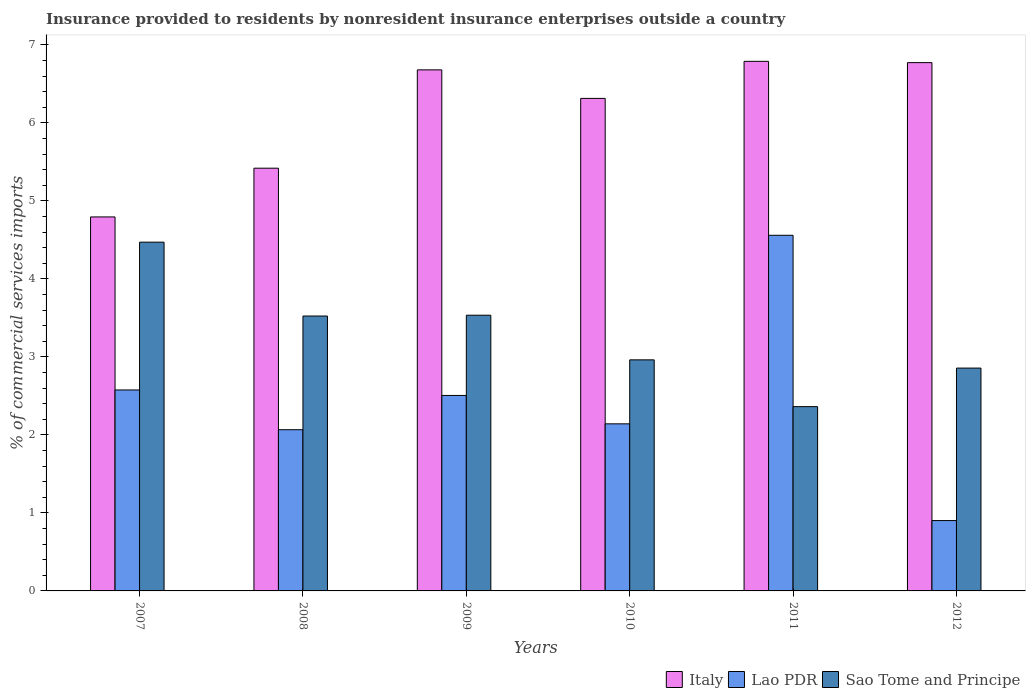Are the number of bars on each tick of the X-axis equal?
Your answer should be compact. Yes. How many bars are there on the 3rd tick from the left?
Give a very brief answer. 3. In how many cases, is the number of bars for a given year not equal to the number of legend labels?
Keep it short and to the point. 0. What is the Insurance provided to residents in Lao PDR in 2009?
Give a very brief answer. 2.51. Across all years, what is the maximum Insurance provided to residents in Lao PDR?
Offer a terse response. 4.56. Across all years, what is the minimum Insurance provided to residents in Italy?
Provide a succinct answer. 4.79. In which year was the Insurance provided to residents in Sao Tome and Principe maximum?
Give a very brief answer. 2007. In which year was the Insurance provided to residents in Sao Tome and Principe minimum?
Provide a short and direct response. 2011. What is the total Insurance provided to residents in Italy in the graph?
Offer a terse response. 36.77. What is the difference between the Insurance provided to residents in Italy in 2007 and that in 2012?
Keep it short and to the point. -1.98. What is the difference between the Insurance provided to residents in Lao PDR in 2008 and the Insurance provided to residents in Italy in 2009?
Your response must be concise. -4.61. What is the average Insurance provided to residents in Sao Tome and Principe per year?
Your answer should be very brief. 3.28. In the year 2012, what is the difference between the Insurance provided to residents in Sao Tome and Principe and Insurance provided to residents in Italy?
Give a very brief answer. -3.92. What is the ratio of the Insurance provided to residents in Italy in 2008 to that in 2010?
Your answer should be very brief. 0.86. What is the difference between the highest and the second highest Insurance provided to residents in Sao Tome and Principe?
Offer a very short reply. 0.94. What is the difference between the highest and the lowest Insurance provided to residents in Sao Tome and Principe?
Your answer should be compact. 2.11. In how many years, is the Insurance provided to residents in Sao Tome and Principe greater than the average Insurance provided to residents in Sao Tome and Principe taken over all years?
Your answer should be very brief. 3. What does the 3rd bar from the left in 2012 represents?
Provide a succinct answer. Sao Tome and Principe. What does the 1st bar from the right in 2012 represents?
Ensure brevity in your answer.  Sao Tome and Principe. Is it the case that in every year, the sum of the Insurance provided to residents in Italy and Insurance provided to residents in Sao Tome and Principe is greater than the Insurance provided to residents in Lao PDR?
Your answer should be compact. Yes. What is the difference between two consecutive major ticks on the Y-axis?
Your answer should be compact. 1. Are the values on the major ticks of Y-axis written in scientific E-notation?
Make the answer very short. No. Does the graph contain grids?
Offer a very short reply. No. Where does the legend appear in the graph?
Offer a very short reply. Bottom right. How many legend labels are there?
Make the answer very short. 3. How are the legend labels stacked?
Provide a succinct answer. Horizontal. What is the title of the graph?
Provide a succinct answer. Insurance provided to residents by nonresident insurance enterprises outside a country. What is the label or title of the Y-axis?
Ensure brevity in your answer.  % of commercial services imports. What is the % of commercial services imports of Italy in 2007?
Keep it short and to the point. 4.79. What is the % of commercial services imports of Lao PDR in 2007?
Provide a succinct answer. 2.58. What is the % of commercial services imports of Sao Tome and Principe in 2007?
Offer a very short reply. 4.47. What is the % of commercial services imports in Italy in 2008?
Provide a short and direct response. 5.42. What is the % of commercial services imports in Lao PDR in 2008?
Provide a short and direct response. 2.07. What is the % of commercial services imports in Sao Tome and Principe in 2008?
Provide a short and direct response. 3.52. What is the % of commercial services imports of Italy in 2009?
Offer a very short reply. 6.68. What is the % of commercial services imports in Lao PDR in 2009?
Offer a very short reply. 2.51. What is the % of commercial services imports of Sao Tome and Principe in 2009?
Your response must be concise. 3.53. What is the % of commercial services imports in Italy in 2010?
Your answer should be compact. 6.31. What is the % of commercial services imports of Lao PDR in 2010?
Your answer should be very brief. 2.14. What is the % of commercial services imports in Sao Tome and Principe in 2010?
Your answer should be compact. 2.96. What is the % of commercial services imports of Italy in 2011?
Offer a very short reply. 6.79. What is the % of commercial services imports of Lao PDR in 2011?
Provide a short and direct response. 4.56. What is the % of commercial services imports in Sao Tome and Principe in 2011?
Your answer should be very brief. 2.36. What is the % of commercial services imports of Italy in 2012?
Your response must be concise. 6.77. What is the % of commercial services imports of Lao PDR in 2012?
Make the answer very short. 0.9. What is the % of commercial services imports in Sao Tome and Principe in 2012?
Offer a terse response. 2.86. Across all years, what is the maximum % of commercial services imports of Italy?
Offer a very short reply. 6.79. Across all years, what is the maximum % of commercial services imports in Lao PDR?
Offer a terse response. 4.56. Across all years, what is the maximum % of commercial services imports in Sao Tome and Principe?
Provide a succinct answer. 4.47. Across all years, what is the minimum % of commercial services imports in Italy?
Your answer should be compact. 4.79. Across all years, what is the minimum % of commercial services imports in Lao PDR?
Provide a short and direct response. 0.9. Across all years, what is the minimum % of commercial services imports in Sao Tome and Principe?
Offer a terse response. 2.36. What is the total % of commercial services imports in Italy in the graph?
Provide a short and direct response. 36.77. What is the total % of commercial services imports in Lao PDR in the graph?
Offer a very short reply. 14.75. What is the total % of commercial services imports in Sao Tome and Principe in the graph?
Provide a succinct answer. 19.71. What is the difference between the % of commercial services imports of Italy in 2007 and that in 2008?
Offer a very short reply. -0.62. What is the difference between the % of commercial services imports of Lao PDR in 2007 and that in 2008?
Keep it short and to the point. 0.51. What is the difference between the % of commercial services imports in Sao Tome and Principe in 2007 and that in 2008?
Give a very brief answer. 0.95. What is the difference between the % of commercial services imports of Italy in 2007 and that in 2009?
Your answer should be compact. -1.89. What is the difference between the % of commercial services imports of Lao PDR in 2007 and that in 2009?
Ensure brevity in your answer.  0.07. What is the difference between the % of commercial services imports in Sao Tome and Principe in 2007 and that in 2009?
Give a very brief answer. 0.94. What is the difference between the % of commercial services imports of Italy in 2007 and that in 2010?
Give a very brief answer. -1.52. What is the difference between the % of commercial services imports of Lao PDR in 2007 and that in 2010?
Your response must be concise. 0.43. What is the difference between the % of commercial services imports of Sao Tome and Principe in 2007 and that in 2010?
Ensure brevity in your answer.  1.51. What is the difference between the % of commercial services imports in Italy in 2007 and that in 2011?
Provide a short and direct response. -1.99. What is the difference between the % of commercial services imports of Lao PDR in 2007 and that in 2011?
Ensure brevity in your answer.  -1.98. What is the difference between the % of commercial services imports of Sao Tome and Principe in 2007 and that in 2011?
Keep it short and to the point. 2.11. What is the difference between the % of commercial services imports of Italy in 2007 and that in 2012?
Ensure brevity in your answer.  -1.98. What is the difference between the % of commercial services imports of Lao PDR in 2007 and that in 2012?
Make the answer very short. 1.67. What is the difference between the % of commercial services imports of Sao Tome and Principe in 2007 and that in 2012?
Your response must be concise. 1.61. What is the difference between the % of commercial services imports of Italy in 2008 and that in 2009?
Your response must be concise. -1.26. What is the difference between the % of commercial services imports of Lao PDR in 2008 and that in 2009?
Ensure brevity in your answer.  -0.44. What is the difference between the % of commercial services imports in Sao Tome and Principe in 2008 and that in 2009?
Your response must be concise. -0.01. What is the difference between the % of commercial services imports in Italy in 2008 and that in 2010?
Your answer should be very brief. -0.89. What is the difference between the % of commercial services imports in Lao PDR in 2008 and that in 2010?
Your answer should be compact. -0.08. What is the difference between the % of commercial services imports of Sao Tome and Principe in 2008 and that in 2010?
Keep it short and to the point. 0.56. What is the difference between the % of commercial services imports of Italy in 2008 and that in 2011?
Provide a succinct answer. -1.37. What is the difference between the % of commercial services imports of Lao PDR in 2008 and that in 2011?
Your answer should be compact. -2.49. What is the difference between the % of commercial services imports in Sao Tome and Principe in 2008 and that in 2011?
Offer a terse response. 1.16. What is the difference between the % of commercial services imports in Italy in 2008 and that in 2012?
Make the answer very short. -1.35. What is the difference between the % of commercial services imports in Lao PDR in 2008 and that in 2012?
Keep it short and to the point. 1.16. What is the difference between the % of commercial services imports of Sao Tome and Principe in 2008 and that in 2012?
Keep it short and to the point. 0.67. What is the difference between the % of commercial services imports in Italy in 2009 and that in 2010?
Your answer should be very brief. 0.37. What is the difference between the % of commercial services imports in Lao PDR in 2009 and that in 2010?
Make the answer very short. 0.36. What is the difference between the % of commercial services imports of Sao Tome and Principe in 2009 and that in 2010?
Offer a terse response. 0.57. What is the difference between the % of commercial services imports of Italy in 2009 and that in 2011?
Provide a succinct answer. -0.11. What is the difference between the % of commercial services imports in Lao PDR in 2009 and that in 2011?
Your answer should be compact. -2.05. What is the difference between the % of commercial services imports of Sao Tome and Principe in 2009 and that in 2011?
Keep it short and to the point. 1.17. What is the difference between the % of commercial services imports of Italy in 2009 and that in 2012?
Offer a very short reply. -0.09. What is the difference between the % of commercial services imports of Lao PDR in 2009 and that in 2012?
Make the answer very short. 1.6. What is the difference between the % of commercial services imports of Sao Tome and Principe in 2009 and that in 2012?
Make the answer very short. 0.68. What is the difference between the % of commercial services imports in Italy in 2010 and that in 2011?
Give a very brief answer. -0.47. What is the difference between the % of commercial services imports of Lao PDR in 2010 and that in 2011?
Offer a terse response. -2.42. What is the difference between the % of commercial services imports in Sao Tome and Principe in 2010 and that in 2011?
Provide a succinct answer. 0.6. What is the difference between the % of commercial services imports of Italy in 2010 and that in 2012?
Give a very brief answer. -0.46. What is the difference between the % of commercial services imports in Lao PDR in 2010 and that in 2012?
Offer a very short reply. 1.24. What is the difference between the % of commercial services imports in Sao Tome and Principe in 2010 and that in 2012?
Provide a succinct answer. 0.11. What is the difference between the % of commercial services imports of Italy in 2011 and that in 2012?
Your answer should be very brief. 0.02. What is the difference between the % of commercial services imports in Lao PDR in 2011 and that in 2012?
Provide a short and direct response. 3.66. What is the difference between the % of commercial services imports of Sao Tome and Principe in 2011 and that in 2012?
Keep it short and to the point. -0.49. What is the difference between the % of commercial services imports in Italy in 2007 and the % of commercial services imports in Lao PDR in 2008?
Offer a very short reply. 2.73. What is the difference between the % of commercial services imports of Italy in 2007 and the % of commercial services imports of Sao Tome and Principe in 2008?
Your response must be concise. 1.27. What is the difference between the % of commercial services imports in Lao PDR in 2007 and the % of commercial services imports in Sao Tome and Principe in 2008?
Offer a terse response. -0.95. What is the difference between the % of commercial services imports in Italy in 2007 and the % of commercial services imports in Lao PDR in 2009?
Ensure brevity in your answer.  2.29. What is the difference between the % of commercial services imports in Italy in 2007 and the % of commercial services imports in Sao Tome and Principe in 2009?
Provide a succinct answer. 1.26. What is the difference between the % of commercial services imports in Lao PDR in 2007 and the % of commercial services imports in Sao Tome and Principe in 2009?
Your response must be concise. -0.96. What is the difference between the % of commercial services imports of Italy in 2007 and the % of commercial services imports of Lao PDR in 2010?
Make the answer very short. 2.65. What is the difference between the % of commercial services imports in Italy in 2007 and the % of commercial services imports in Sao Tome and Principe in 2010?
Offer a very short reply. 1.83. What is the difference between the % of commercial services imports of Lao PDR in 2007 and the % of commercial services imports of Sao Tome and Principe in 2010?
Provide a short and direct response. -0.39. What is the difference between the % of commercial services imports of Italy in 2007 and the % of commercial services imports of Lao PDR in 2011?
Your answer should be very brief. 0.24. What is the difference between the % of commercial services imports in Italy in 2007 and the % of commercial services imports in Sao Tome and Principe in 2011?
Keep it short and to the point. 2.43. What is the difference between the % of commercial services imports in Lao PDR in 2007 and the % of commercial services imports in Sao Tome and Principe in 2011?
Give a very brief answer. 0.21. What is the difference between the % of commercial services imports in Italy in 2007 and the % of commercial services imports in Lao PDR in 2012?
Your response must be concise. 3.89. What is the difference between the % of commercial services imports in Italy in 2007 and the % of commercial services imports in Sao Tome and Principe in 2012?
Keep it short and to the point. 1.94. What is the difference between the % of commercial services imports in Lao PDR in 2007 and the % of commercial services imports in Sao Tome and Principe in 2012?
Provide a short and direct response. -0.28. What is the difference between the % of commercial services imports of Italy in 2008 and the % of commercial services imports of Lao PDR in 2009?
Your answer should be compact. 2.91. What is the difference between the % of commercial services imports of Italy in 2008 and the % of commercial services imports of Sao Tome and Principe in 2009?
Your answer should be compact. 1.88. What is the difference between the % of commercial services imports of Lao PDR in 2008 and the % of commercial services imports of Sao Tome and Principe in 2009?
Provide a succinct answer. -1.47. What is the difference between the % of commercial services imports of Italy in 2008 and the % of commercial services imports of Lao PDR in 2010?
Give a very brief answer. 3.28. What is the difference between the % of commercial services imports in Italy in 2008 and the % of commercial services imports in Sao Tome and Principe in 2010?
Give a very brief answer. 2.46. What is the difference between the % of commercial services imports of Lao PDR in 2008 and the % of commercial services imports of Sao Tome and Principe in 2010?
Provide a succinct answer. -0.9. What is the difference between the % of commercial services imports in Italy in 2008 and the % of commercial services imports in Lao PDR in 2011?
Your response must be concise. 0.86. What is the difference between the % of commercial services imports of Italy in 2008 and the % of commercial services imports of Sao Tome and Principe in 2011?
Keep it short and to the point. 3.06. What is the difference between the % of commercial services imports of Lao PDR in 2008 and the % of commercial services imports of Sao Tome and Principe in 2011?
Ensure brevity in your answer.  -0.3. What is the difference between the % of commercial services imports of Italy in 2008 and the % of commercial services imports of Lao PDR in 2012?
Your answer should be very brief. 4.52. What is the difference between the % of commercial services imports in Italy in 2008 and the % of commercial services imports in Sao Tome and Principe in 2012?
Provide a succinct answer. 2.56. What is the difference between the % of commercial services imports in Lao PDR in 2008 and the % of commercial services imports in Sao Tome and Principe in 2012?
Keep it short and to the point. -0.79. What is the difference between the % of commercial services imports of Italy in 2009 and the % of commercial services imports of Lao PDR in 2010?
Make the answer very short. 4.54. What is the difference between the % of commercial services imports in Italy in 2009 and the % of commercial services imports in Sao Tome and Principe in 2010?
Offer a very short reply. 3.72. What is the difference between the % of commercial services imports of Lao PDR in 2009 and the % of commercial services imports of Sao Tome and Principe in 2010?
Ensure brevity in your answer.  -0.46. What is the difference between the % of commercial services imports of Italy in 2009 and the % of commercial services imports of Lao PDR in 2011?
Ensure brevity in your answer.  2.12. What is the difference between the % of commercial services imports in Italy in 2009 and the % of commercial services imports in Sao Tome and Principe in 2011?
Your answer should be compact. 4.32. What is the difference between the % of commercial services imports of Lao PDR in 2009 and the % of commercial services imports of Sao Tome and Principe in 2011?
Keep it short and to the point. 0.14. What is the difference between the % of commercial services imports in Italy in 2009 and the % of commercial services imports in Lao PDR in 2012?
Provide a short and direct response. 5.78. What is the difference between the % of commercial services imports of Italy in 2009 and the % of commercial services imports of Sao Tome and Principe in 2012?
Provide a succinct answer. 3.82. What is the difference between the % of commercial services imports in Lao PDR in 2009 and the % of commercial services imports in Sao Tome and Principe in 2012?
Provide a succinct answer. -0.35. What is the difference between the % of commercial services imports of Italy in 2010 and the % of commercial services imports of Lao PDR in 2011?
Offer a terse response. 1.75. What is the difference between the % of commercial services imports in Italy in 2010 and the % of commercial services imports in Sao Tome and Principe in 2011?
Keep it short and to the point. 3.95. What is the difference between the % of commercial services imports of Lao PDR in 2010 and the % of commercial services imports of Sao Tome and Principe in 2011?
Your response must be concise. -0.22. What is the difference between the % of commercial services imports in Italy in 2010 and the % of commercial services imports in Lao PDR in 2012?
Offer a terse response. 5.41. What is the difference between the % of commercial services imports of Italy in 2010 and the % of commercial services imports of Sao Tome and Principe in 2012?
Provide a short and direct response. 3.46. What is the difference between the % of commercial services imports of Lao PDR in 2010 and the % of commercial services imports of Sao Tome and Principe in 2012?
Give a very brief answer. -0.71. What is the difference between the % of commercial services imports of Italy in 2011 and the % of commercial services imports of Lao PDR in 2012?
Ensure brevity in your answer.  5.89. What is the difference between the % of commercial services imports of Italy in 2011 and the % of commercial services imports of Sao Tome and Principe in 2012?
Offer a very short reply. 3.93. What is the difference between the % of commercial services imports in Lao PDR in 2011 and the % of commercial services imports in Sao Tome and Principe in 2012?
Ensure brevity in your answer.  1.7. What is the average % of commercial services imports in Italy per year?
Your response must be concise. 6.13. What is the average % of commercial services imports in Lao PDR per year?
Your answer should be compact. 2.46. What is the average % of commercial services imports in Sao Tome and Principe per year?
Your answer should be very brief. 3.29. In the year 2007, what is the difference between the % of commercial services imports of Italy and % of commercial services imports of Lao PDR?
Keep it short and to the point. 2.22. In the year 2007, what is the difference between the % of commercial services imports in Italy and % of commercial services imports in Sao Tome and Principe?
Offer a terse response. 0.32. In the year 2007, what is the difference between the % of commercial services imports in Lao PDR and % of commercial services imports in Sao Tome and Principe?
Provide a succinct answer. -1.89. In the year 2008, what is the difference between the % of commercial services imports in Italy and % of commercial services imports in Lao PDR?
Your response must be concise. 3.35. In the year 2008, what is the difference between the % of commercial services imports in Italy and % of commercial services imports in Sao Tome and Principe?
Provide a short and direct response. 1.9. In the year 2008, what is the difference between the % of commercial services imports of Lao PDR and % of commercial services imports of Sao Tome and Principe?
Ensure brevity in your answer.  -1.46. In the year 2009, what is the difference between the % of commercial services imports in Italy and % of commercial services imports in Lao PDR?
Your response must be concise. 4.17. In the year 2009, what is the difference between the % of commercial services imports of Italy and % of commercial services imports of Sao Tome and Principe?
Provide a short and direct response. 3.15. In the year 2009, what is the difference between the % of commercial services imports in Lao PDR and % of commercial services imports in Sao Tome and Principe?
Offer a terse response. -1.03. In the year 2010, what is the difference between the % of commercial services imports in Italy and % of commercial services imports in Lao PDR?
Provide a succinct answer. 4.17. In the year 2010, what is the difference between the % of commercial services imports of Italy and % of commercial services imports of Sao Tome and Principe?
Give a very brief answer. 3.35. In the year 2010, what is the difference between the % of commercial services imports of Lao PDR and % of commercial services imports of Sao Tome and Principe?
Offer a very short reply. -0.82. In the year 2011, what is the difference between the % of commercial services imports of Italy and % of commercial services imports of Lao PDR?
Give a very brief answer. 2.23. In the year 2011, what is the difference between the % of commercial services imports in Italy and % of commercial services imports in Sao Tome and Principe?
Provide a short and direct response. 4.43. In the year 2011, what is the difference between the % of commercial services imports in Lao PDR and % of commercial services imports in Sao Tome and Principe?
Your response must be concise. 2.2. In the year 2012, what is the difference between the % of commercial services imports in Italy and % of commercial services imports in Lao PDR?
Your response must be concise. 5.87. In the year 2012, what is the difference between the % of commercial services imports of Italy and % of commercial services imports of Sao Tome and Principe?
Give a very brief answer. 3.92. In the year 2012, what is the difference between the % of commercial services imports of Lao PDR and % of commercial services imports of Sao Tome and Principe?
Your answer should be compact. -1.95. What is the ratio of the % of commercial services imports of Italy in 2007 to that in 2008?
Provide a succinct answer. 0.88. What is the ratio of the % of commercial services imports of Lao PDR in 2007 to that in 2008?
Provide a short and direct response. 1.25. What is the ratio of the % of commercial services imports in Sao Tome and Principe in 2007 to that in 2008?
Make the answer very short. 1.27. What is the ratio of the % of commercial services imports in Italy in 2007 to that in 2009?
Provide a succinct answer. 0.72. What is the ratio of the % of commercial services imports of Lao PDR in 2007 to that in 2009?
Give a very brief answer. 1.03. What is the ratio of the % of commercial services imports in Sao Tome and Principe in 2007 to that in 2009?
Offer a very short reply. 1.26. What is the ratio of the % of commercial services imports in Italy in 2007 to that in 2010?
Provide a short and direct response. 0.76. What is the ratio of the % of commercial services imports of Lao PDR in 2007 to that in 2010?
Give a very brief answer. 1.2. What is the ratio of the % of commercial services imports of Sao Tome and Principe in 2007 to that in 2010?
Offer a terse response. 1.51. What is the ratio of the % of commercial services imports in Italy in 2007 to that in 2011?
Your answer should be compact. 0.71. What is the ratio of the % of commercial services imports in Lao PDR in 2007 to that in 2011?
Your answer should be compact. 0.57. What is the ratio of the % of commercial services imports of Sao Tome and Principe in 2007 to that in 2011?
Keep it short and to the point. 1.89. What is the ratio of the % of commercial services imports in Italy in 2007 to that in 2012?
Keep it short and to the point. 0.71. What is the ratio of the % of commercial services imports in Lao PDR in 2007 to that in 2012?
Your answer should be compact. 2.86. What is the ratio of the % of commercial services imports of Sao Tome and Principe in 2007 to that in 2012?
Keep it short and to the point. 1.56. What is the ratio of the % of commercial services imports in Italy in 2008 to that in 2009?
Provide a short and direct response. 0.81. What is the ratio of the % of commercial services imports in Lao PDR in 2008 to that in 2009?
Your answer should be compact. 0.82. What is the ratio of the % of commercial services imports in Italy in 2008 to that in 2010?
Offer a terse response. 0.86. What is the ratio of the % of commercial services imports in Lao PDR in 2008 to that in 2010?
Your response must be concise. 0.96. What is the ratio of the % of commercial services imports in Sao Tome and Principe in 2008 to that in 2010?
Give a very brief answer. 1.19. What is the ratio of the % of commercial services imports in Italy in 2008 to that in 2011?
Keep it short and to the point. 0.8. What is the ratio of the % of commercial services imports of Lao PDR in 2008 to that in 2011?
Your answer should be very brief. 0.45. What is the ratio of the % of commercial services imports of Sao Tome and Principe in 2008 to that in 2011?
Make the answer very short. 1.49. What is the ratio of the % of commercial services imports in Italy in 2008 to that in 2012?
Provide a short and direct response. 0.8. What is the ratio of the % of commercial services imports of Lao PDR in 2008 to that in 2012?
Your answer should be compact. 2.29. What is the ratio of the % of commercial services imports of Sao Tome and Principe in 2008 to that in 2012?
Make the answer very short. 1.23. What is the ratio of the % of commercial services imports of Italy in 2009 to that in 2010?
Give a very brief answer. 1.06. What is the ratio of the % of commercial services imports in Lao PDR in 2009 to that in 2010?
Give a very brief answer. 1.17. What is the ratio of the % of commercial services imports of Sao Tome and Principe in 2009 to that in 2010?
Provide a short and direct response. 1.19. What is the ratio of the % of commercial services imports in Italy in 2009 to that in 2011?
Make the answer very short. 0.98. What is the ratio of the % of commercial services imports in Lao PDR in 2009 to that in 2011?
Your answer should be very brief. 0.55. What is the ratio of the % of commercial services imports in Sao Tome and Principe in 2009 to that in 2011?
Ensure brevity in your answer.  1.5. What is the ratio of the % of commercial services imports in Italy in 2009 to that in 2012?
Provide a short and direct response. 0.99. What is the ratio of the % of commercial services imports of Lao PDR in 2009 to that in 2012?
Offer a terse response. 2.78. What is the ratio of the % of commercial services imports in Sao Tome and Principe in 2009 to that in 2012?
Offer a terse response. 1.24. What is the ratio of the % of commercial services imports in Italy in 2010 to that in 2011?
Offer a terse response. 0.93. What is the ratio of the % of commercial services imports in Lao PDR in 2010 to that in 2011?
Give a very brief answer. 0.47. What is the ratio of the % of commercial services imports in Sao Tome and Principe in 2010 to that in 2011?
Offer a terse response. 1.25. What is the ratio of the % of commercial services imports in Italy in 2010 to that in 2012?
Offer a terse response. 0.93. What is the ratio of the % of commercial services imports of Lao PDR in 2010 to that in 2012?
Keep it short and to the point. 2.38. What is the ratio of the % of commercial services imports of Sao Tome and Principe in 2010 to that in 2012?
Offer a terse response. 1.04. What is the ratio of the % of commercial services imports in Italy in 2011 to that in 2012?
Your answer should be very brief. 1. What is the ratio of the % of commercial services imports of Lao PDR in 2011 to that in 2012?
Make the answer very short. 5.06. What is the ratio of the % of commercial services imports of Sao Tome and Principe in 2011 to that in 2012?
Give a very brief answer. 0.83. What is the difference between the highest and the second highest % of commercial services imports of Italy?
Offer a terse response. 0.02. What is the difference between the highest and the second highest % of commercial services imports of Lao PDR?
Your response must be concise. 1.98. What is the difference between the highest and the second highest % of commercial services imports of Sao Tome and Principe?
Your answer should be very brief. 0.94. What is the difference between the highest and the lowest % of commercial services imports of Italy?
Your answer should be compact. 1.99. What is the difference between the highest and the lowest % of commercial services imports of Lao PDR?
Offer a terse response. 3.66. What is the difference between the highest and the lowest % of commercial services imports of Sao Tome and Principe?
Provide a succinct answer. 2.11. 